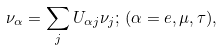<formula> <loc_0><loc_0><loc_500><loc_500>\nu _ { \alpha } = \sum _ { j } U _ { \alpha j } \nu _ { j } ; \, ( \alpha = e , \mu , \tau ) ,</formula> 